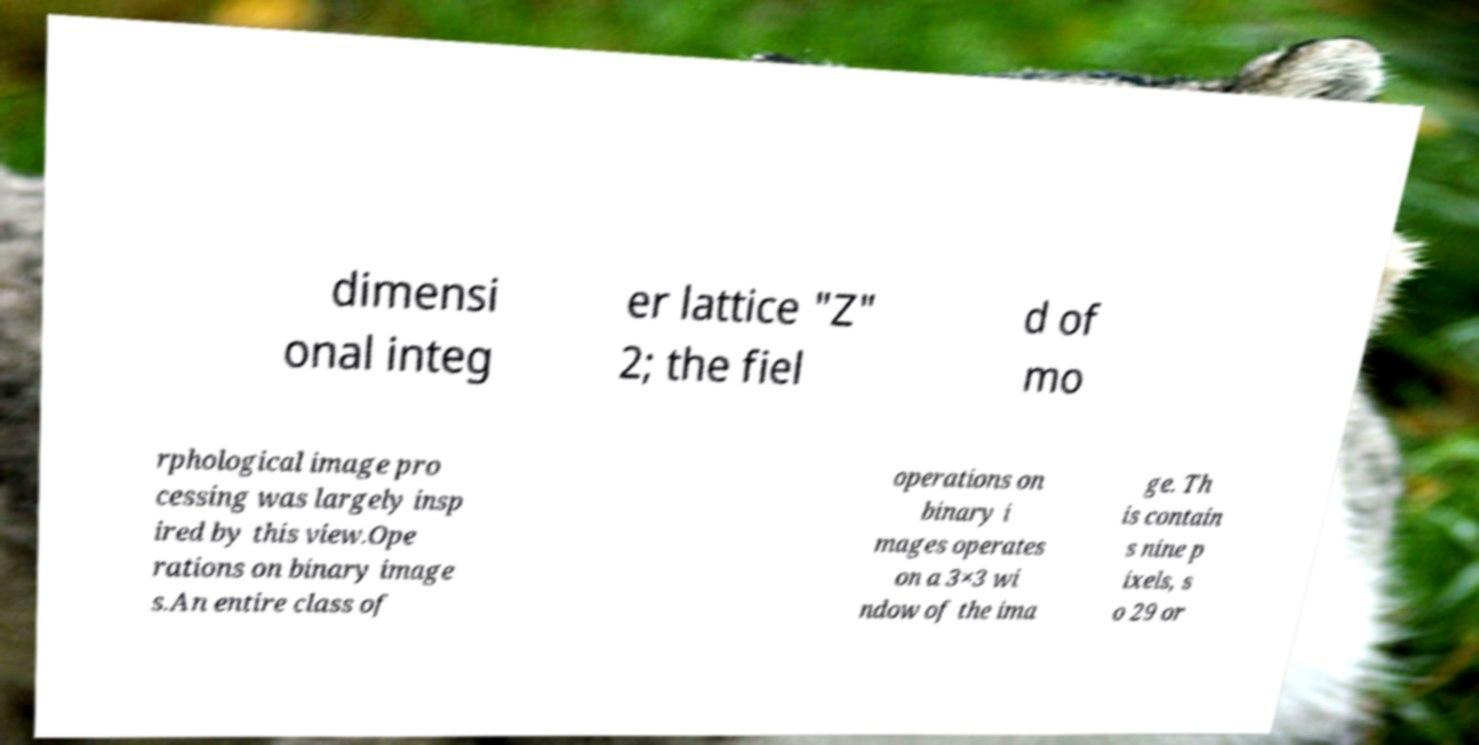Please read and relay the text visible in this image. What does it say? dimensi onal integ er lattice "Z" 2; the fiel d of mo rphological image pro cessing was largely insp ired by this view.Ope rations on binary image s.An entire class of operations on binary i mages operates on a 3×3 wi ndow of the ima ge. Th is contain s nine p ixels, s o 29 or 